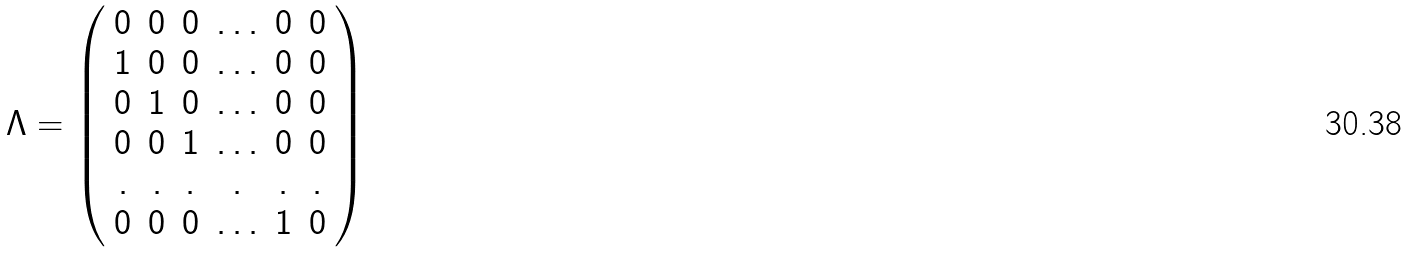Convert formula to latex. <formula><loc_0><loc_0><loc_500><loc_500>\Lambda = \left ( \begin{array} { c c c c c c } { 0 } & { 0 } & { 0 } & { \dots } & { 0 } & { 0 } \\ { 1 } & { 0 } & { 0 } & { \dots } & { 0 } & { 0 } \\ { 0 } & { 1 } & { 0 } & { \dots } & { 0 } & { 0 } \\ { 0 } & { 0 } & { 1 } & { \dots } & { 0 } & { 0 } \\ { . } & { . } & { . } & { . } & { . } & { . } \\ { 0 } & { 0 } & { 0 } & { \dots } & { 1 } & { 0 } \end{array} \right )</formula> 